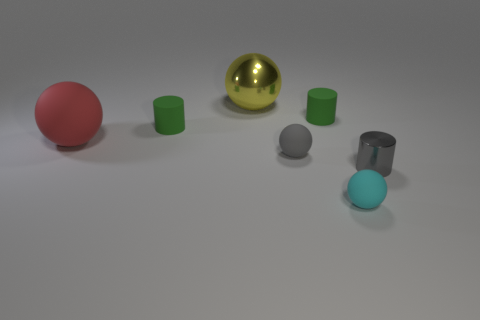Subtract all tiny gray shiny cylinders. How many cylinders are left? 2 Subtract all cyan spheres. How many green cylinders are left? 2 Subtract all gray balls. How many balls are left? 3 Subtract 1 balls. How many balls are left? 3 Add 3 tiny red cylinders. How many objects exist? 10 Subtract all purple cylinders. Subtract all brown cubes. How many cylinders are left? 3 Add 4 gray balls. How many gray balls are left? 5 Add 5 small blue matte cubes. How many small blue matte cubes exist? 5 Subtract 0 blue cylinders. How many objects are left? 7 Subtract all balls. How many objects are left? 3 